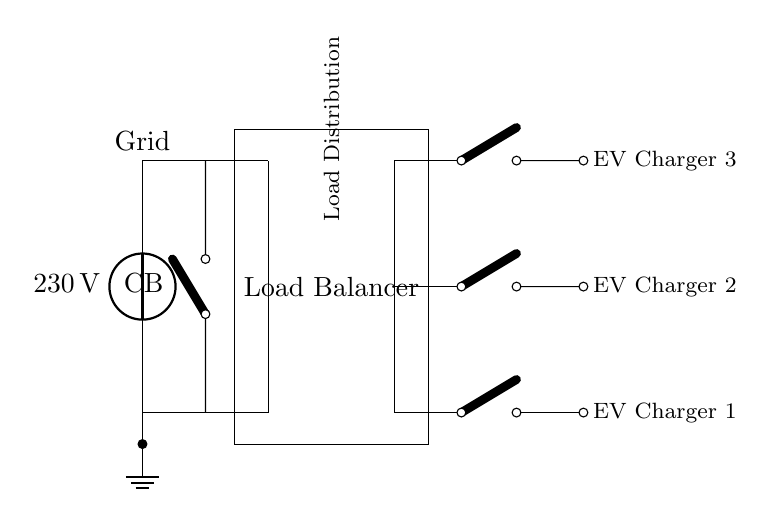What is the voltage of this circuit? The voltage source in the circuit diagram specifies a voltage of 230 volts. This information is directly indicated in the diagram label at the voltage source component.
Answer: 230 volts What type of switch is used in this circuit? The circuit contains a 'cute open switch', which is specifically labeled next to the switch components. This terminology defines the type of switch being used.
Answer: Cute open switch How many electric vehicle chargers are present? There are 3 electric vehicle chargers indicated in the circuit diagram, as shown by the count of the labeled 'EV Charger' components. Each charger is positioned at different vertical levels in the diagram.
Answer: 3 What component is responsible for load balancing? The component labeled 'Load Balancer' in the circuit diagram represents the load balancing function. It is clearly depicted as a rectangle within the circuit layout.
Answer: Load Balancer What is connected to the grid in this circuit? The grid is connected to the voltage source component, which provides the necessary electrical power to the entire circuit layout. This connection is illustrated at the beginning of the circuit.
Answer: Voltage source Why is a transformer included in this circuit? The transformer in the circuit is included to step down or modify the voltage level for compatibility with the load and electric vehicle chargers, ensuring safe and efficient operation. The position and connection to the circuit further clarify this role.
Answer: To modify voltage levels 